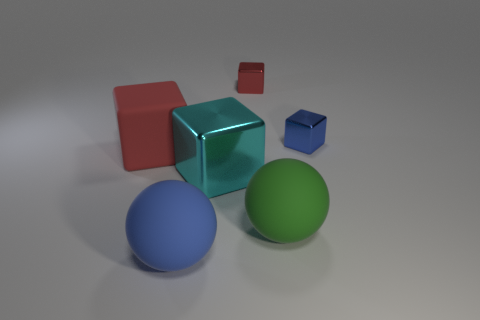Subtract all blue blocks. How many blocks are left? 3 Add 1 large yellow rubber spheres. How many objects exist? 7 Subtract all green balls. How many balls are left? 1 Add 3 large spheres. How many large spheres are left? 5 Add 2 red metal blocks. How many red metal blocks exist? 3 Subtract 0 red balls. How many objects are left? 6 Subtract all spheres. How many objects are left? 4 Subtract 1 spheres. How many spheres are left? 1 Subtract all blue spheres. Subtract all gray cubes. How many spheres are left? 1 Subtract all brown spheres. How many brown blocks are left? 0 